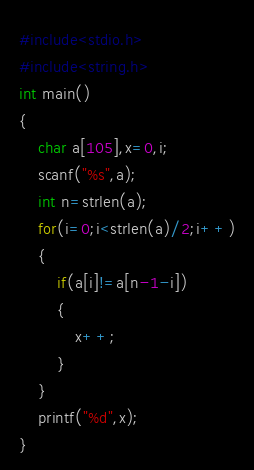<code> <loc_0><loc_0><loc_500><loc_500><_C++_>#include<stdio.h>
#include<string.h>
int main()
{
	char a[105],x=0,i;
	scanf("%s",a);
	int n=strlen(a);
	for(i=0;i<strlen(a)/2;i++)
    {
    	if(a[i]!=a[n-1-i])
    	{
    		x++;
		}
	}
	printf("%d",x);
} </code> 